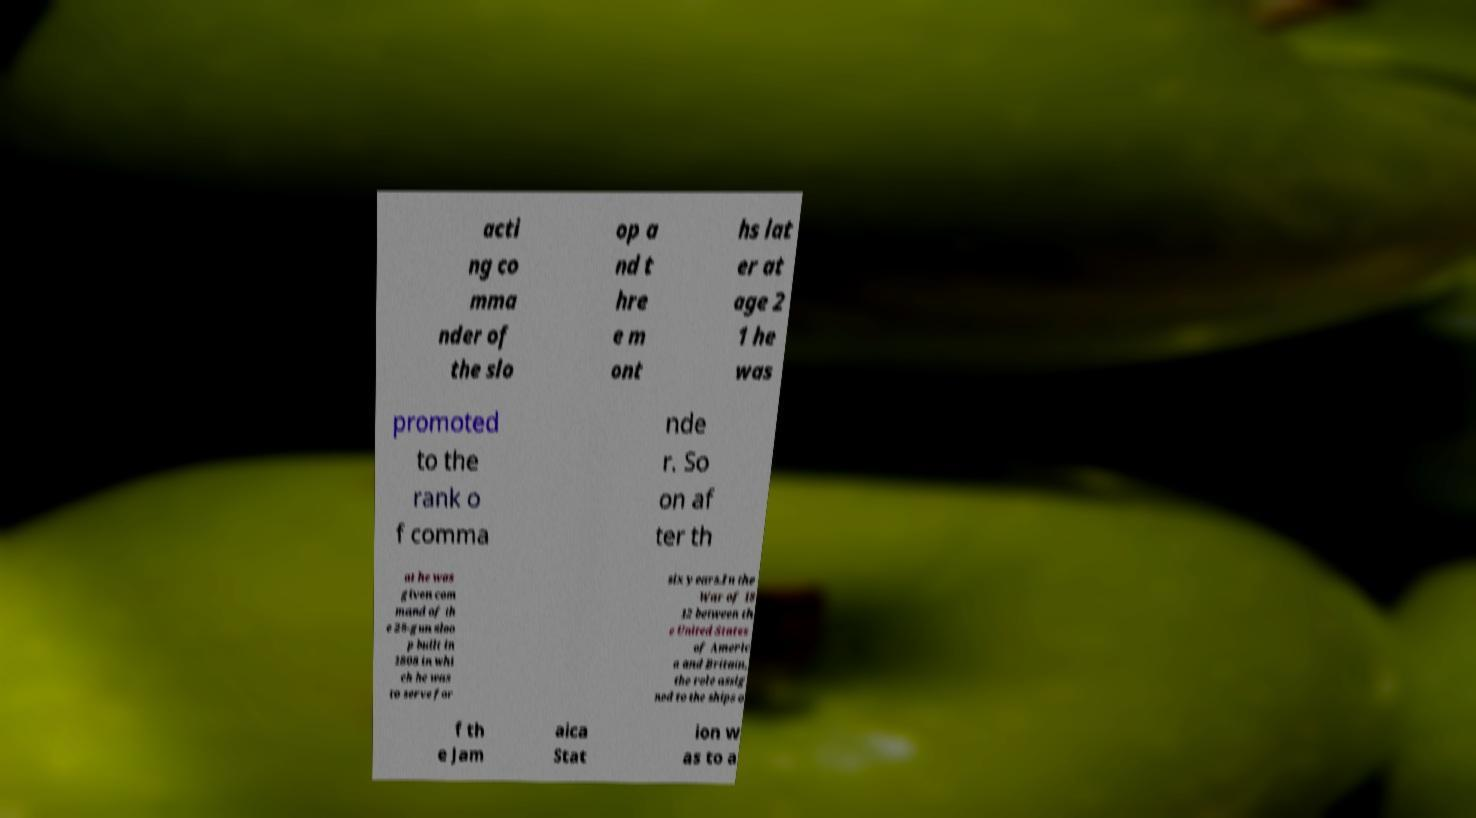For documentation purposes, I need the text within this image transcribed. Could you provide that? acti ng co mma nder of the slo op a nd t hre e m ont hs lat er at age 2 1 he was promoted to the rank o f comma nde r. So on af ter th at he was given com mand of th e 28-gun sloo p built in 1808 in whi ch he was to serve for six years.In the War of 18 12 between th e United States of Americ a and Britain, the role assig ned to the ships o f th e Jam aica Stat ion w as to a 